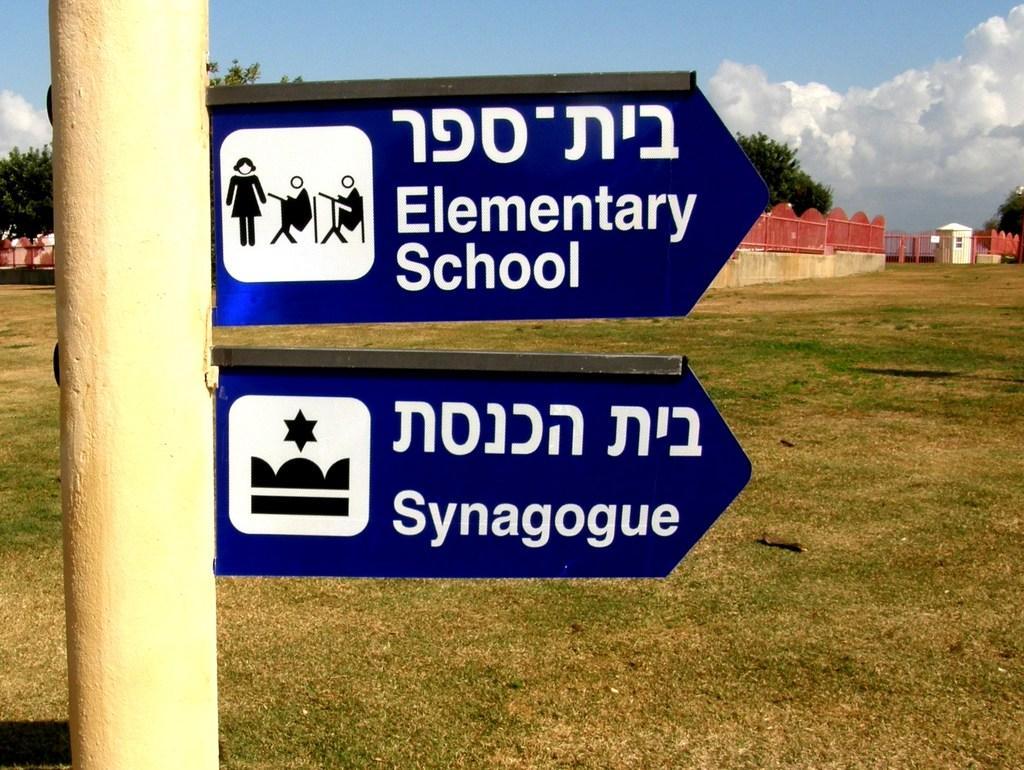In one or two sentences, can you explain what this image depicts? In this image there is a pole in the middle to which there are two birds. At the bottom there is a ground on which there is grass. In the background there is a wall on which there is red color fence. At the top there is the sky. There are trees behind the fence. On the right side top there is a small hut. 